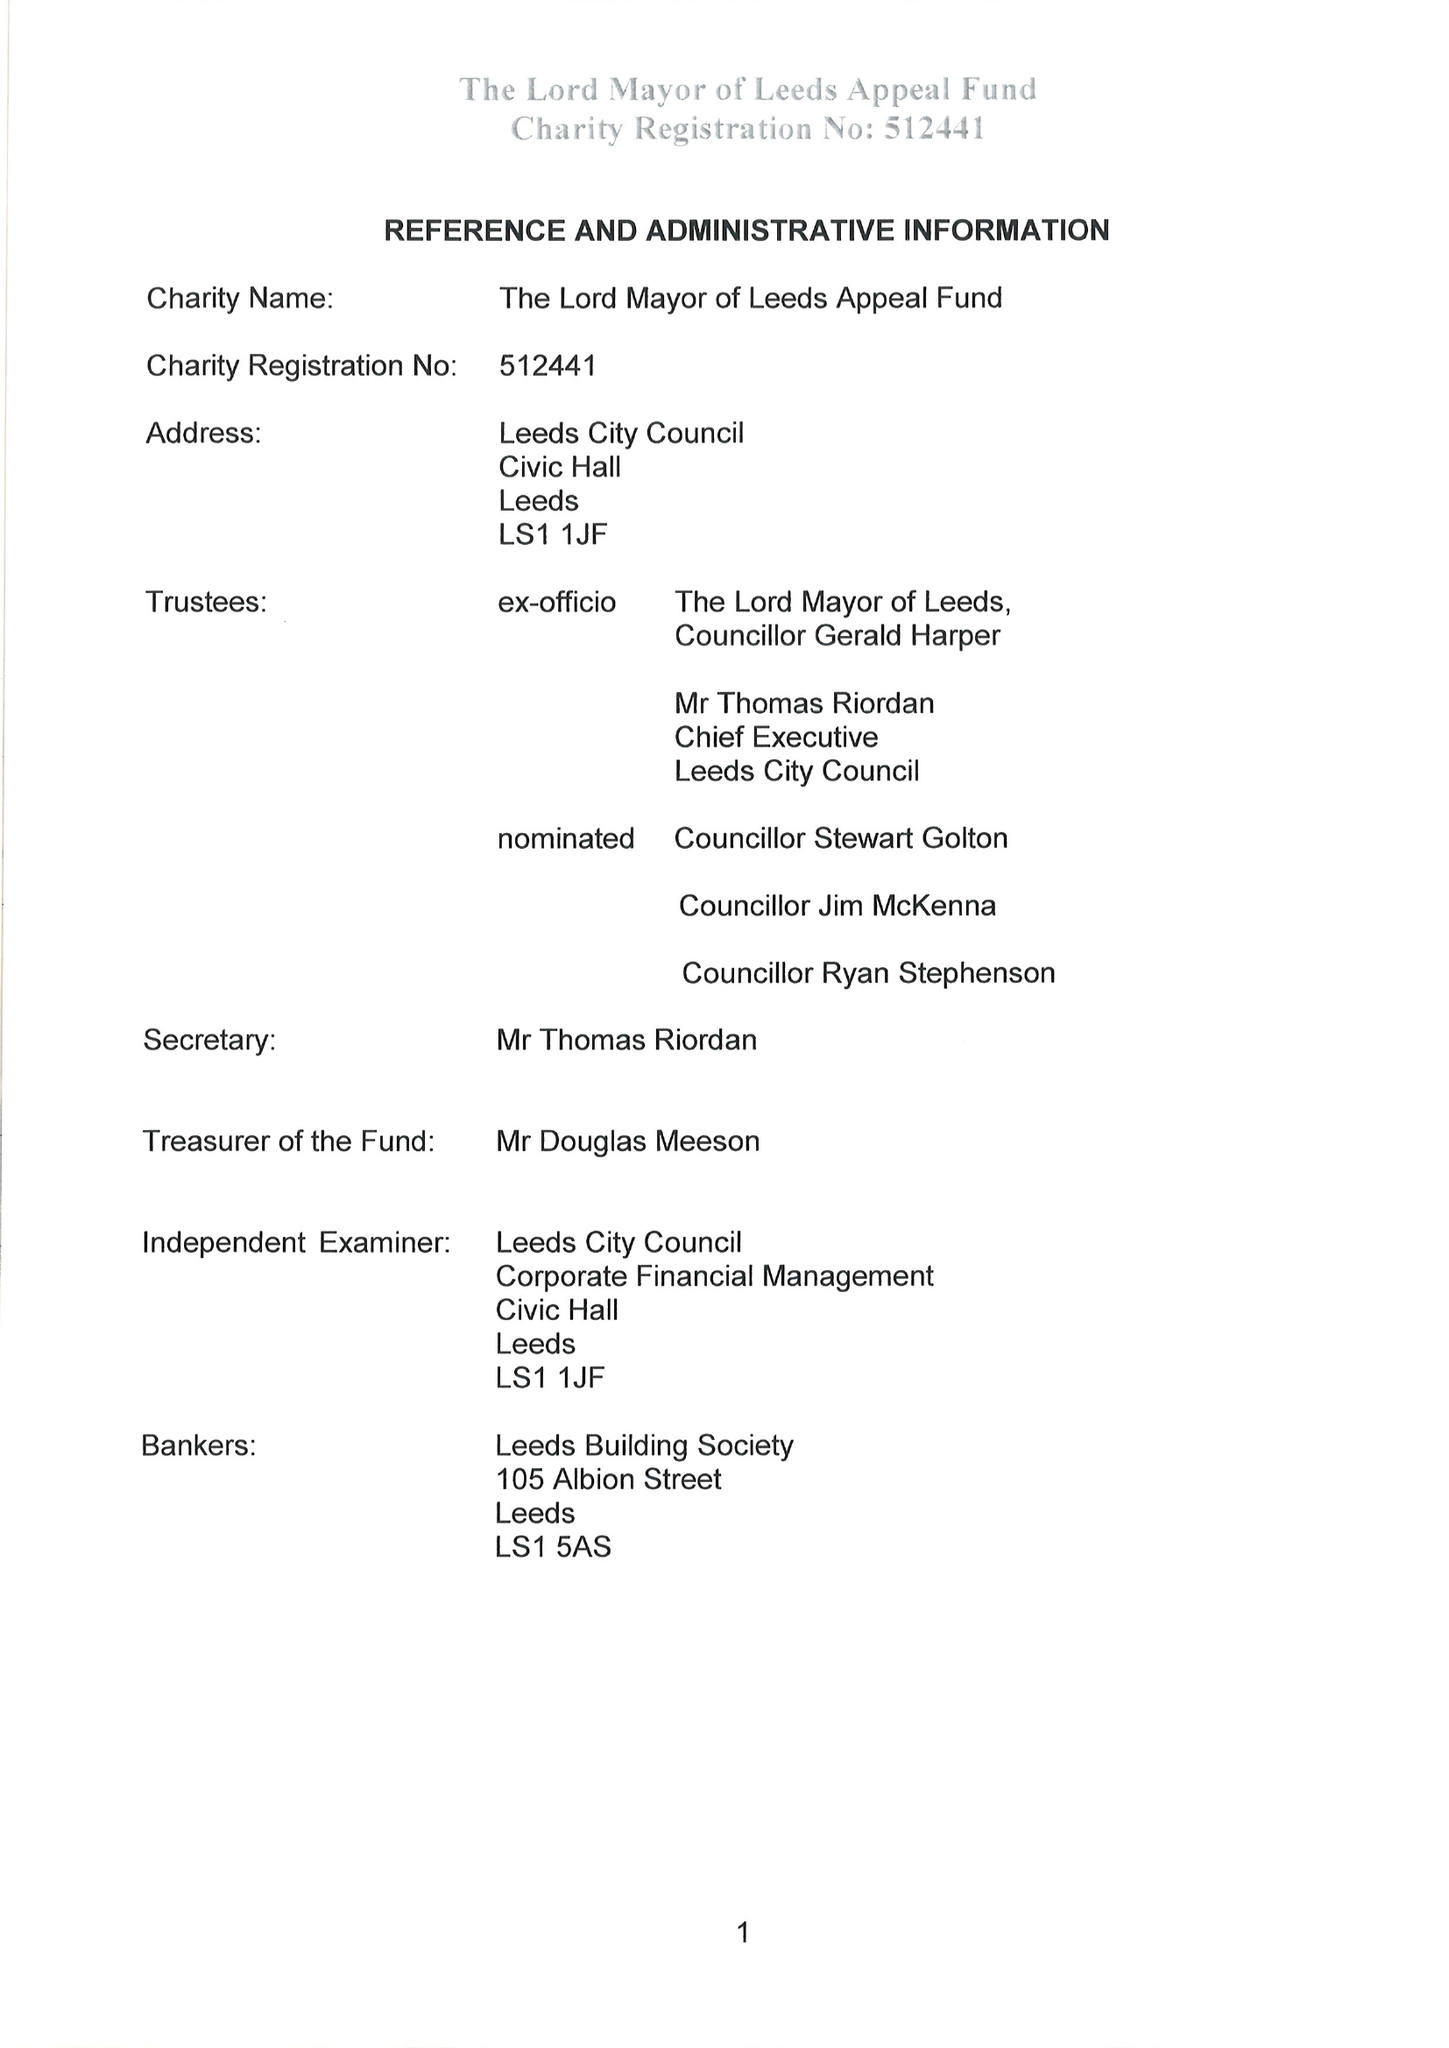What is the value for the income_annually_in_british_pounds?
Answer the question using a single word or phrase. 50688.00 